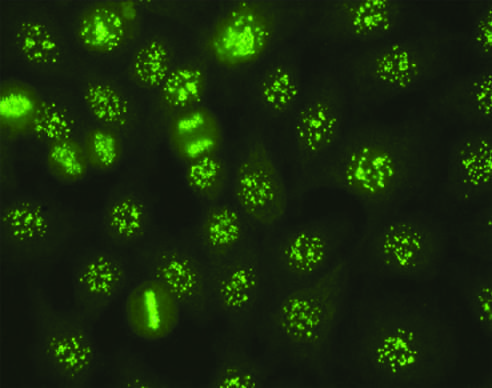re neutrophils seen in some cases of systemic sclerosis, sjogren syndrome, and other diseases?
Answer the question using a single word or phrase. No 